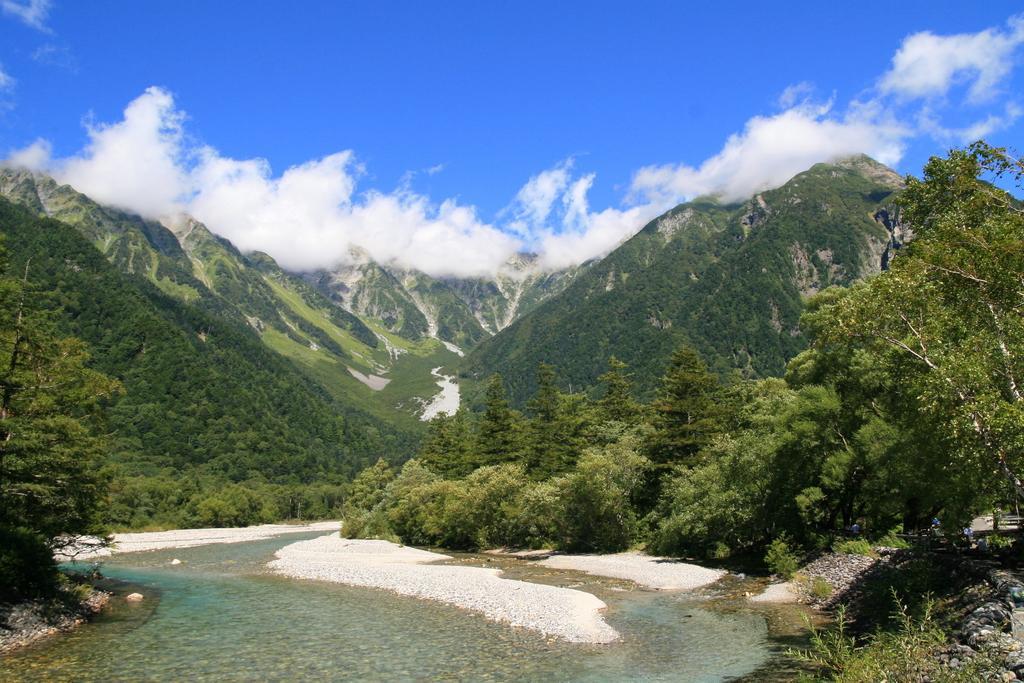Could you give a brief overview of what you see in this image? In this picture we can see water at the bottom, on the right side and left side there are trees, we can see hills in the background, at the right bottom we can see some plants, there is the sky and clouds at the top of the picture. 